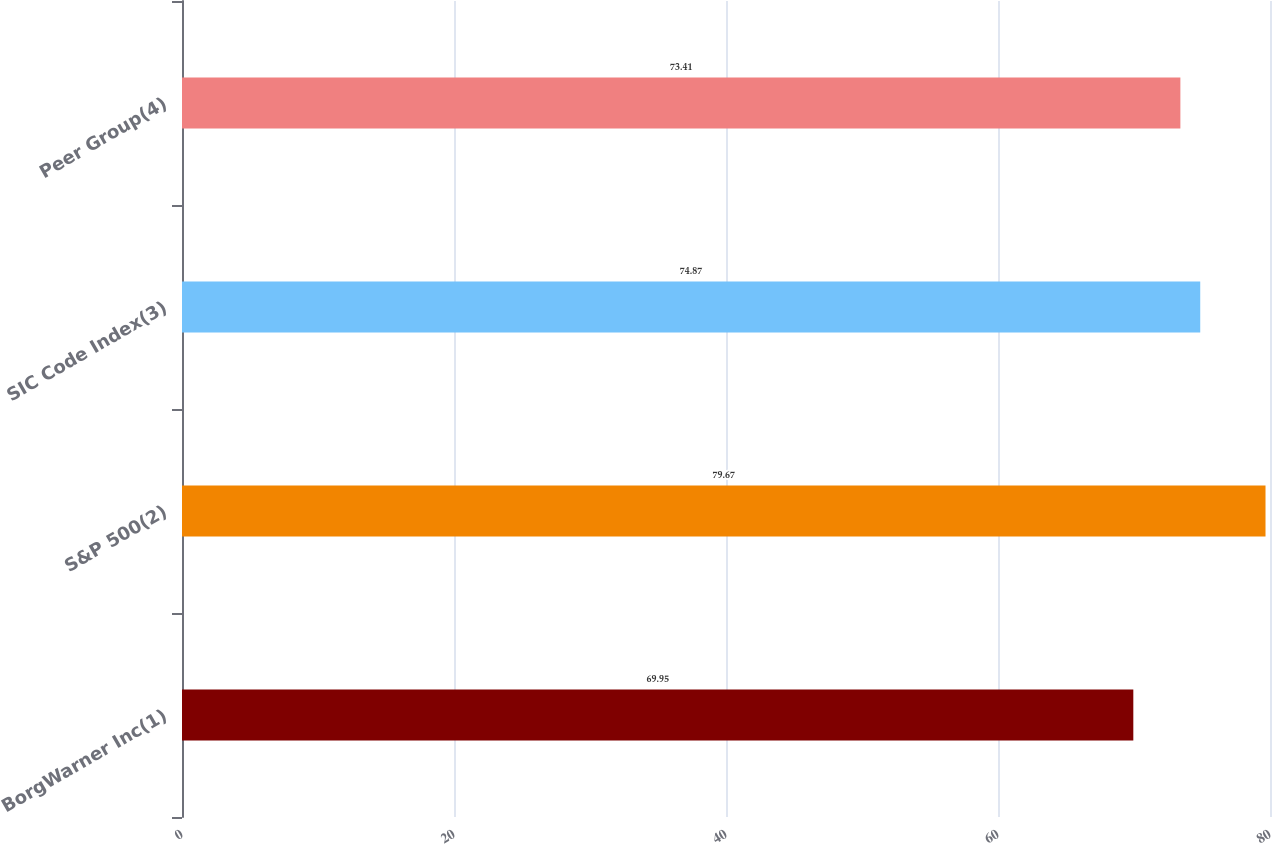Convert chart. <chart><loc_0><loc_0><loc_500><loc_500><bar_chart><fcel>BorgWarner Inc(1)<fcel>S&P 500(2)<fcel>SIC Code Index(3)<fcel>Peer Group(4)<nl><fcel>69.95<fcel>79.67<fcel>74.87<fcel>73.41<nl></chart> 